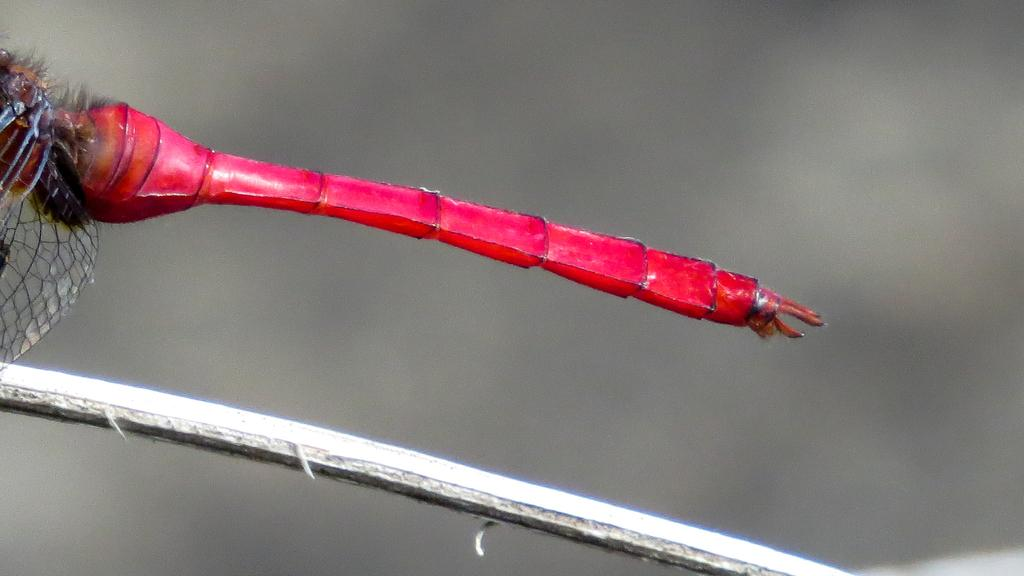What is in the center of the image? There is a stick in the center of the image. What is on the stick? There is a dragonfly on the stick. What color is the dragonfly? The dragonfly is red in color. Where is the volcano located in the image? There is no volcano present in the image. Is the dragonfly wearing a crown in the image? There is no crown visible on the dragonfly in the image. 